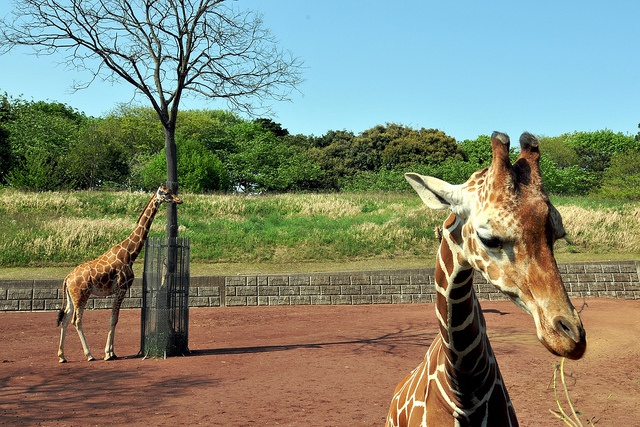Describe the objects in this image and their specific colors. I can see giraffe in lightblue, black, brown, tan, and khaki tones and giraffe in lightblue, black, maroon, and gray tones in this image. 